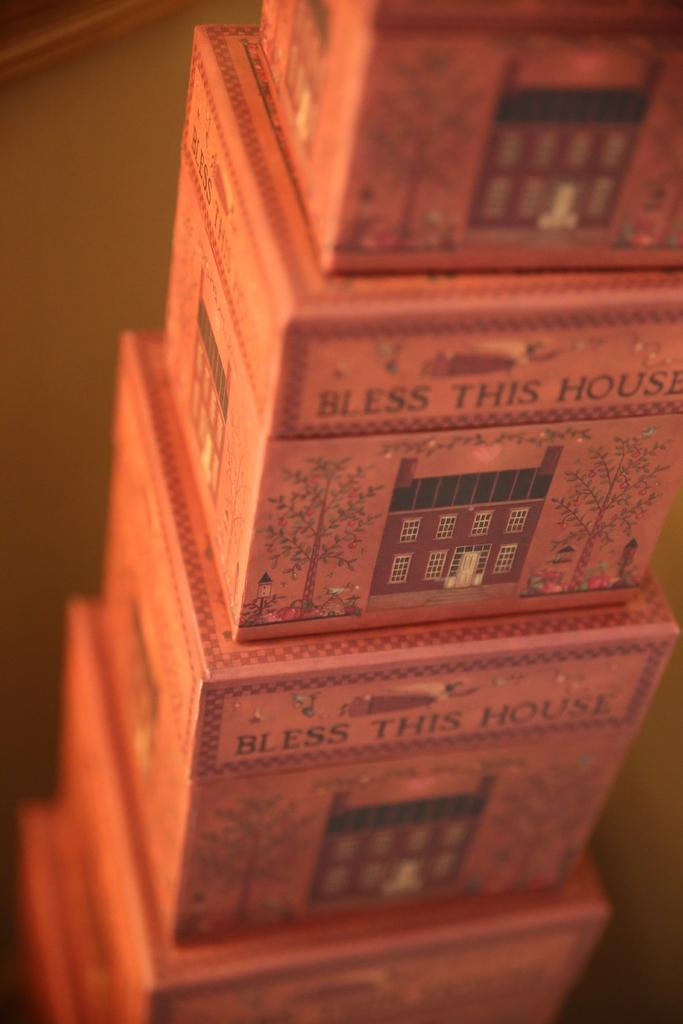Provide a one-sentence caption for the provided image. Many boxes that say "bless this house" are stacked on top of each other. 